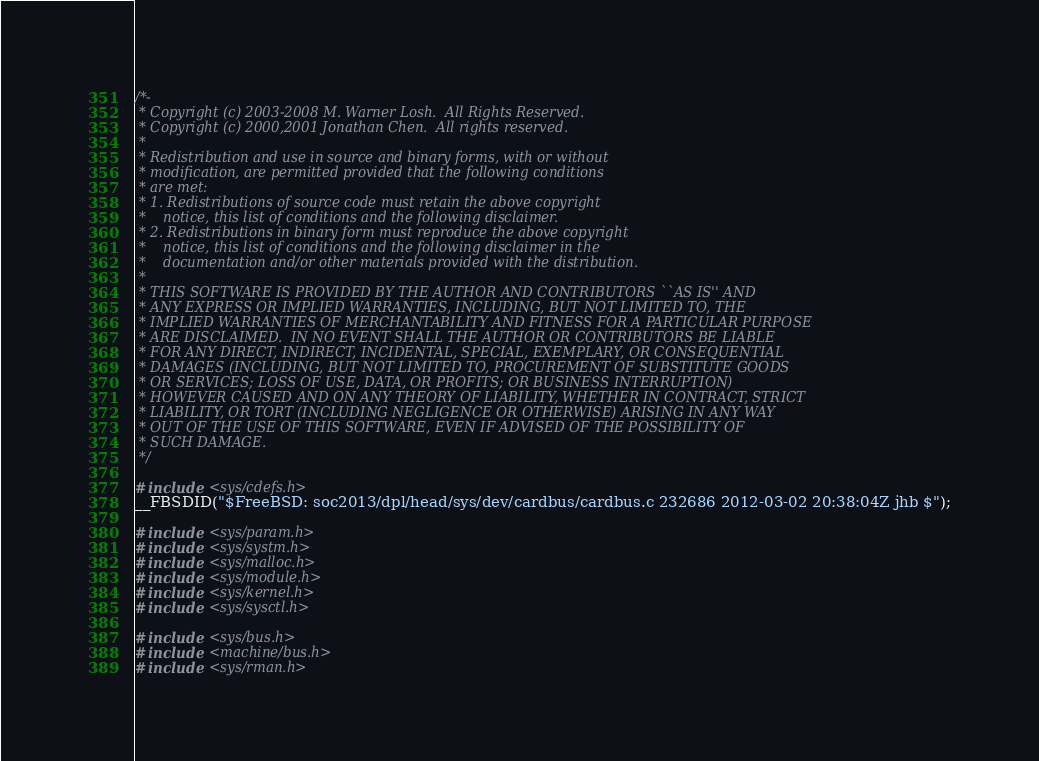Convert code to text. <code><loc_0><loc_0><loc_500><loc_500><_C_>/*-
 * Copyright (c) 2003-2008 M. Warner Losh.  All Rights Reserved.
 * Copyright (c) 2000,2001 Jonathan Chen.  All rights reserved.
 *
 * Redistribution and use in source and binary forms, with or without
 * modification, are permitted provided that the following conditions
 * are met:
 * 1. Redistributions of source code must retain the above copyright
 *    notice, this list of conditions and the following disclaimer.
 * 2. Redistributions in binary form must reproduce the above copyright
 *    notice, this list of conditions and the following disclaimer in the
 *    documentation and/or other materials provided with the distribution.
 *
 * THIS SOFTWARE IS PROVIDED BY THE AUTHOR AND CONTRIBUTORS ``AS IS'' AND
 * ANY EXPRESS OR IMPLIED WARRANTIES, INCLUDING, BUT NOT LIMITED TO, THE
 * IMPLIED WARRANTIES OF MERCHANTABILITY AND FITNESS FOR A PARTICULAR PURPOSE
 * ARE DISCLAIMED.  IN NO EVENT SHALL THE AUTHOR OR CONTRIBUTORS BE LIABLE
 * FOR ANY DIRECT, INDIRECT, INCIDENTAL, SPECIAL, EXEMPLARY, OR CONSEQUENTIAL
 * DAMAGES (INCLUDING, BUT NOT LIMITED TO, PROCUREMENT OF SUBSTITUTE GOODS
 * OR SERVICES; LOSS OF USE, DATA, OR PROFITS; OR BUSINESS INTERRUPTION)
 * HOWEVER CAUSED AND ON ANY THEORY OF LIABILITY, WHETHER IN CONTRACT, STRICT
 * LIABILITY, OR TORT (INCLUDING NEGLIGENCE OR OTHERWISE) ARISING IN ANY WAY
 * OUT OF THE USE OF THIS SOFTWARE, EVEN IF ADVISED OF THE POSSIBILITY OF
 * SUCH DAMAGE.
 */

#include <sys/cdefs.h>
__FBSDID("$FreeBSD: soc2013/dpl/head/sys/dev/cardbus/cardbus.c 232686 2012-03-02 20:38:04Z jhb $");

#include <sys/param.h>
#include <sys/systm.h>
#include <sys/malloc.h>
#include <sys/module.h>
#include <sys/kernel.h>
#include <sys/sysctl.h>

#include <sys/bus.h>
#include <machine/bus.h>
#include <sys/rman.h></code> 